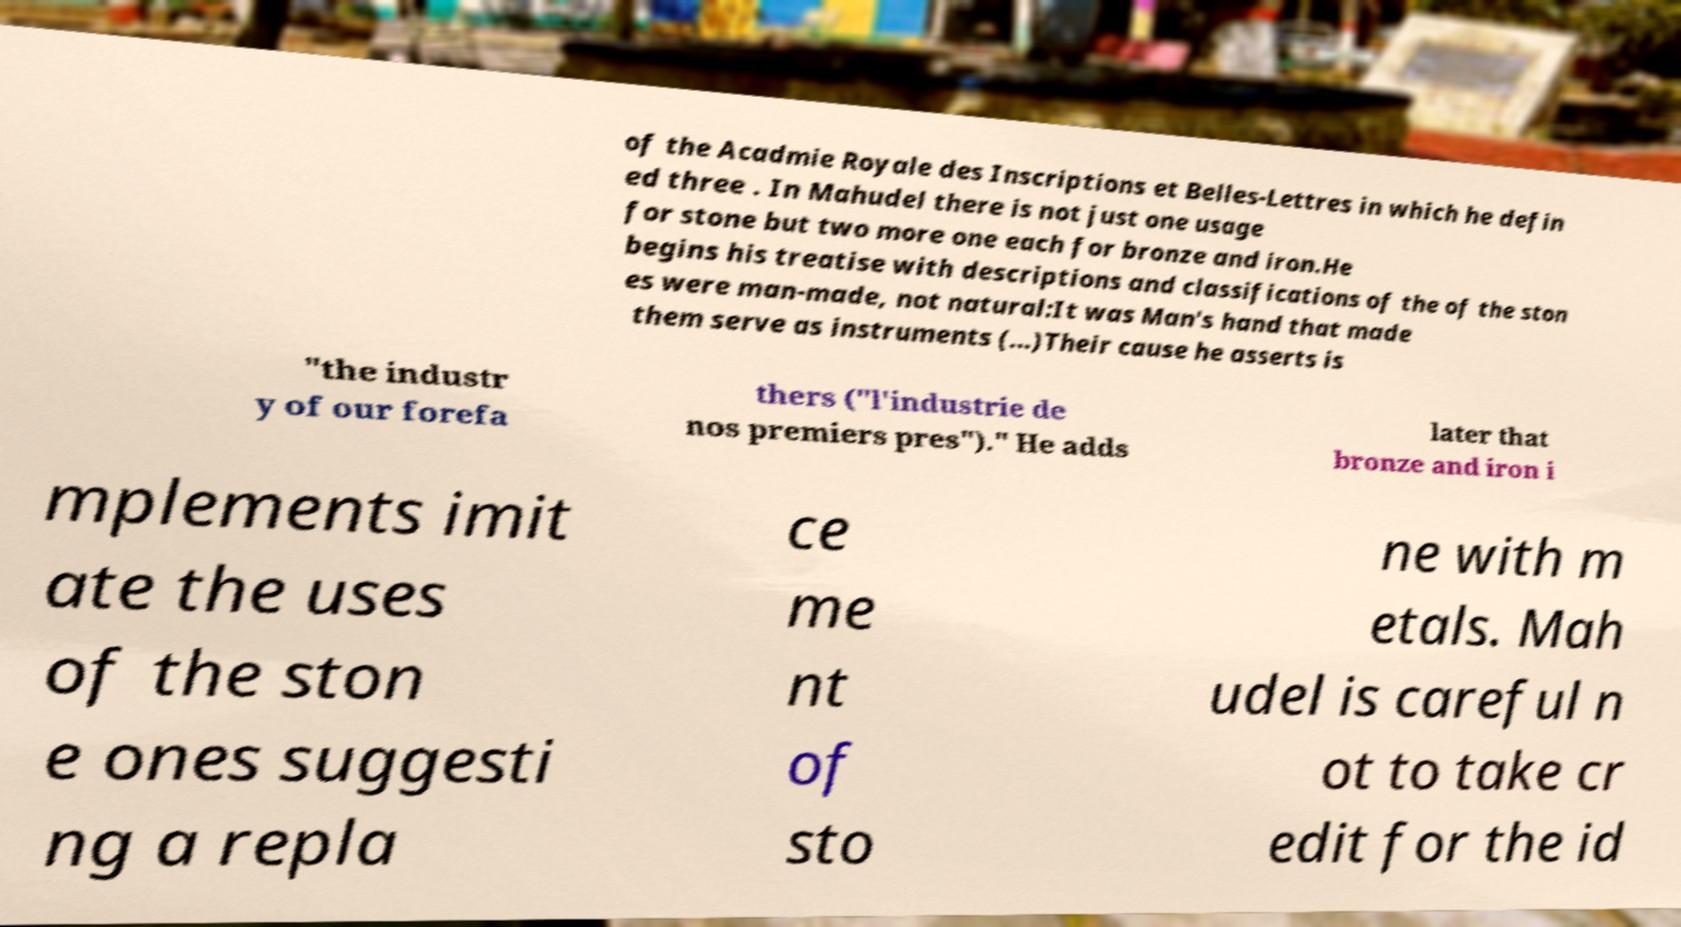Please read and relay the text visible in this image. What does it say? of the Acadmie Royale des Inscriptions et Belles-Lettres in which he defin ed three . In Mahudel there is not just one usage for stone but two more one each for bronze and iron.He begins his treatise with descriptions and classifications of the of the ston es were man-made, not natural:It was Man's hand that made them serve as instruments (...)Their cause he asserts is "the industr y of our forefa thers ("l'industrie de nos premiers pres")." He adds later that bronze and iron i mplements imit ate the uses of the ston e ones suggesti ng a repla ce me nt of sto ne with m etals. Mah udel is careful n ot to take cr edit for the id 